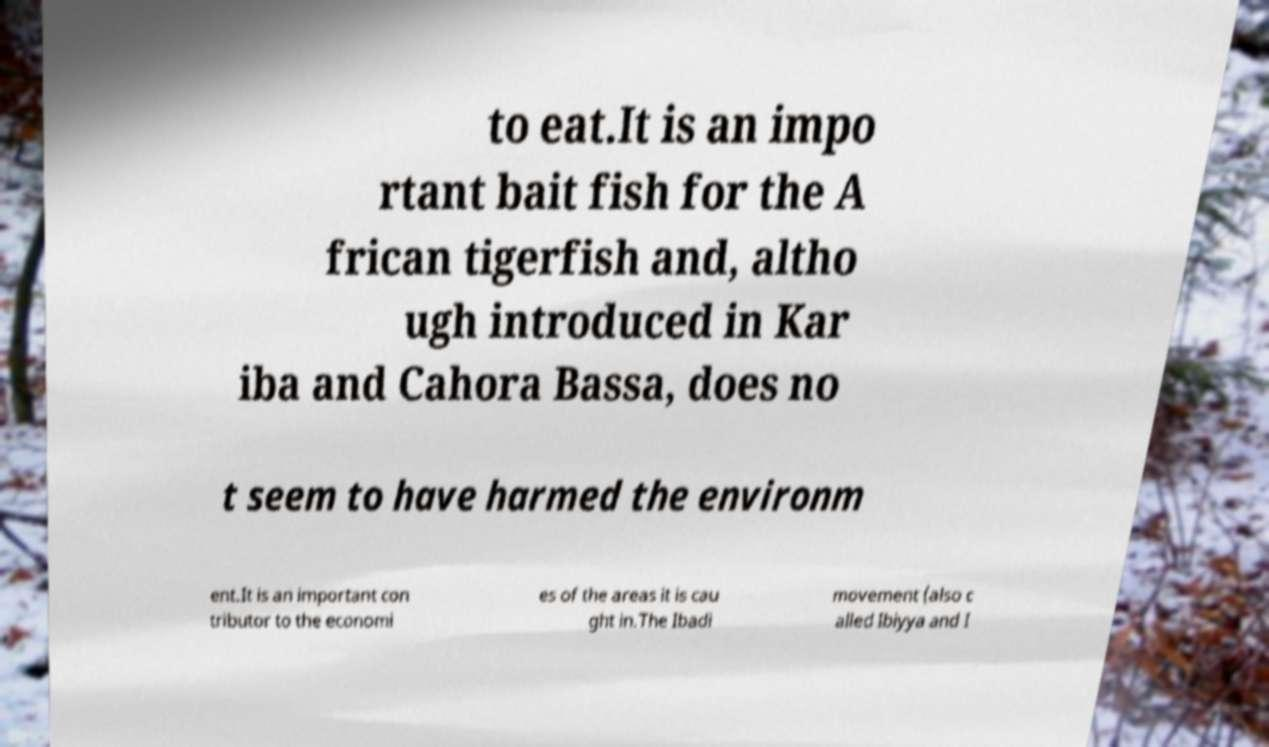Can you read and provide the text displayed in the image?This photo seems to have some interesting text. Can you extract and type it out for me? to eat.It is an impo rtant bait fish for the A frican tigerfish and, altho ugh introduced in Kar iba and Cahora Bassa, does no t seem to have harmed the environm ent.It is an important con tributor to the economi es of the areas it is cau ght in.The Ibadi movement (also c alled Ibiyya and I 